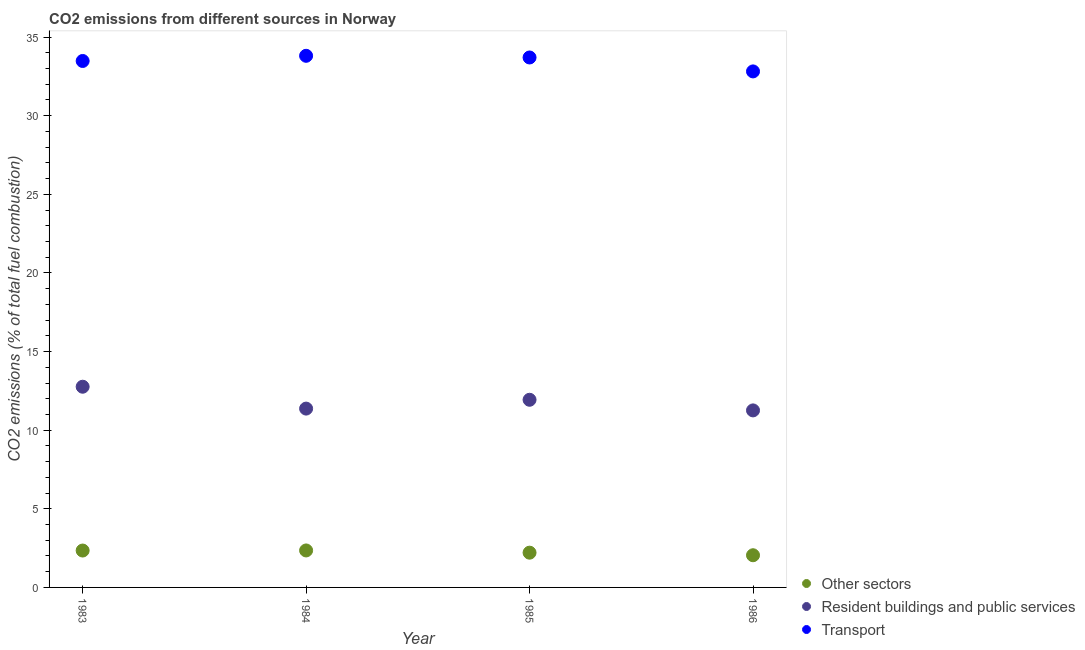What is the percentage of co2 emissions from other sectors in 1986?
Provide a succinct answer. 2.05. Across all years, what is the maximum percentage of co2 emissions from resident buildings and public services?
Your response must be concise. 12.76. Across all years, what is the minimum percentage of co2 emissions from other sectors?
Ensure brevity in your answer.  2.05. What is the total percentage of co2 emissions from transport in the graph?
Ensure brevity in your answer.  133.81. What is the difference between the percentage of co2 emissions from other sectors in 1983 and that in 1984?
Offer a very short reply. -0.01. What is the difference between the percentage of co2 emissions from other sectors in 1985 and the percentage of co2 emissions from resident buildings and public services in 1984?
Offer a terse response. -9.16. What is the average percentage of co2 emissions from resident buildings and public services per year?
Offer a very short reply. 11.83. In the year 1985, what is the difference between the percentage of co2 emissions from other sectors and percentage of co2 emissions from resident buildings and public services?
Your response must be concise. -9.72. What is the ratio of the percentage of co2 emissions from other sectors in 1984 to that in 1985?
Provide a short and direct response. 1.06. Is the difference between the percentage of co2 emissions from resident buildings and public services in 1984 and 1985 greater than the difference between the percentage of co2 emissions from other sectors in 1984 and 1985?
Provide a short and direct response. No. What is the difference between the highest and the second highest percentage of co2 emissions from other sectors?
Make the answer very short. 0.01. What is the difference between the highest and the lowest percentage of co2 emissions from transport?
Provide a succinct answer. 0.99. In how many years, is the percentage of co2 emissions from other sectors greater than the average percentage of co2 emissions from other sectors taken over all years?
Provide a succinct answer. 2. Is the sum of the percentage of co2 emissions from other sectors in 1984 and 1986 greater than the maximum percentage of co2 emissions from transport across all years?
Provide a short and direct response. No. Does the percentage of co2 emissions from other sectors monotonically increase over the years?
Give a very brief answer. No. Is the percentage of co2 emissions from transport strictly less than the percentage of co2 emissions from other sectors over the years?
Give a very brief answer. No. Are the values on the major ticks of Y-axis written in scientific E-notation?
Provide a succinct answer. No. Does the graph contain grids?
Offer a terse response. No. Where does the legend appear in the graph?
Your answer should be compact. Bottom right. How many legend labels are there?
Your answer should be compact. 3. What is the title of the graph?
Provide a succinct answer. CO2 emissions from different sources in Norway. What is the label or title of the Y-axis?
Ensure brevity in your answer.  CO2 emissions (% of total fuel combustion). What is the CO2 emissions (% of total fuel combustion) of Other sectors in 1983?
Give a very brief answer. 2.35. What is the CO2 emissions (% of total fuel combustion) in Resident buildings and public services in 1983?
Provide a succinct answer. 12.76. What is the CO2 emissions (% of total fuel combustion) of Transport in 1983?
Your answer should be compact. 33.48. What is the CO2 emissions (% of total fuel combustion) of Other sectors in 1984?
Your answer should be compact. 2.35. What is the CO2 emissions (% of total fuel combustion) in Resident buildings and public services in 1984?
Ensure brevity in your answer.  11.37. What is the CO2 emissions (% of total fuel combustion) of Transport in 1984?
Make the answer very short. 33.81. What is the CO2 emissions (% of total fuel combustion) of Other sectors in 1985?
Your answer should be very brief. 2.21. What is the CO2 emissions (% of total fuel combustion) of Resident buildings and public services in 1985?
Offer a very short reply. 11.93. What is the CO2 emissions (% of total fuel combustion) in Transport in 1985?
Offer a very short reply. 33.7. What is the CO2 emissions (% of total fuel combustion) of Other sectors in 1986?
Ensure brevity in your answer.  2.05. What is the CO2 emissions (% of total fuel combustion) of Resident buildings and public services in 1986?
Make the answer very short. 11.26. What is the CO2 emissions (% of total fuel combustion) in Transport in 1986?
Keep it short and to the point. 32.82. Across all years, what is the maximum CO2 emissions (% of total fuel combustion) of Other sectors?
Make the answer very short. 2.35. Across all years, what is the maximum CO2 emissions (% of total fuel combustion) of Resident buildings and public services?
Keep it short and to the point. 12.76. Across all years, what is the maximum CO2 emissions (% of total fuel combustion) in Transport?
Offer a very short reply. 33.81. Across all years, what is the minimum CO2 emissions (% of total fuel combustion) in Other sectors?
Offer a terse response. 2.05. Across all years, what is the minimum CO2 emissions (% of total fuel combustion) of Resident buildings and public services?
Offer a terse response. 11.26. Across all years, what is the minimum CO2 emissions (% of total fuel combustion) of Transport?
Offer a terse response. 32.82. What is the total CO2 emissions (% of total fuel combustion) in Other sectors in the graph?
Provide a short and direct response. 8.95. What is the total CO2 emissions (% of total fuel combustion) of Resident buildings and public services in the graph?
Make the answer very short. 47.33. What is the total CO2 emissions (% of total fuel combustion) of Transport in the graph?
Offer a terse response. 133.81. What is the difference between the CO2 emissions (% of total fuel combustion) of Other sectors in 1983 and that in 1984?
Provide a succinct answer. -0.01. What is the difference between the CO2 emissions (% of total fuel combustion) of Resident buildings and public services in 1983 and that in 1984?
Your answer should be very brief. 1.39. What is the difference between the CO2 emissions (% of total fuel combustion) of Transport in 1983 and that in 1984?
Your answer should be compact. -0.33. What is the difference between the CO2 emissions (% of total fuel combustion) in Other sectors in 1983 and that in 1985?
Give a very brief answer. 0.14. What is the difference between the CO2 emissions (% of total fuel combustion) of Resident buildings and public services in 1983 and that in 1985?
Provide a short and direct response. 0.83. What is the difference between the CO2 emissions (% of total fuel combustion) in Transport in 1983 and that in 1985?
Keep it short and to the point. -0.22. What is the difference between the CO2 emissions (% of total fuel combustion) of Other sectors in 1983 and that in 1986?
Your answer should be compact. 0.3. What is the difference between the CO2 emissions (% of total fuel combustion) of Resident buildings and public services in 1983 and that in 1986?
Give a very brief answer. 1.51. What is the difference between the CO2 emissions (% of total fuel combustion) in Transport in 1983 and that in 1986?
Your answer should be compact. 0.66. What is the difference between the CO2 emissions (% of total fuel combustion) in Other sectors in 1984 and that in 1985?
Your answer should be compact. 0.14. What is the difference between the CO2 emissions (% of total fuel combustion) of Resident buildings and public services in 1984 and that in 1985?
Provide a succinct answer. -0.56. What is the difference between the CO2 emissions (% of total fuel combustion) of Transport in 1984 and that in 1985?
Your answer should be very brief. 0.11. What is the difference between the CO2 emissions (% of total fuel combustion) of Other sectors in 1984 and that in 1986?
Provide a succinct answer. 0.3. What is the difference between the CO2 emissions (% of total fuel combustion) of Resident buildings and public services in 1984 and that in 1986?
Ensure brevity in your answer.  0.11. What is the difference between the CO2 emissions (% of total fuel combustion) of Other sectors in 1985 and that in 1986?
Give a very brief answer. 0.16. What is the difference between the CO2 emissions (% of total fuel combustion) of Resident buildings and public services in 1985 and that in 1986?
Offer a terse response. 0.68. What is the difference between the CO2 emissions (% of total fuel combustion) in Transport in 1985 and that in 1986?
Your answer should be very brief. 0.89. What is the difference between the CO2 emissions (% of total fuel combustion) of Other sectors in 1983 and the CO2 emissions (% of total fuel combustion) of Resident buildings and public services in 1984?
Your answer should be compact. -9.03. What is the difference between the CO2 emissions (% of total fuel combustion) in Other sectors in 1983 and the CO2 emissions (% of total fuel combustion) in Transport in 1984?
Provide a short and direct response. -31.46. What is the difference between the CO2 emissions (% of total fuel combustion) in Resident buildings and public services in 1983 and the CO2 emissions (% of total fuel combustion) in Transport in 1984?
Offer a terse response. -21.05. What is the difference between the CO2 emissions (% of total fuel combustion) in Other sectors in 1983 and the CO2 emissions (% of total fuel combustion) in Resident buildings and public services in 1985?
Give a very brief answer. -9.59. What is the difference between the CO2 emissions (% of total fuel combustion) of Other sectors in 1983 and the CO2 emissions (% of total fuel combustion) of Transport in 1985?
Your answer should be very brief. -31.36. What is the difference between the CO2 emissions (% of total fuel combustion) in Resident buildings and public services in 1983 and the CO2 emissions (% of total fuel combustion) in Transport in 1985?
Give a very brief answer. -20.94. What is the difference between the CO2 emissions (% of total fuel combustion) of Other sectors in 1983 and the CO2 emissions (% of total fuel combustion) of Resident buildings and public services in 1986?
Keep it short and to the point. -8.91. What is the difference between the CO2 emissions (% of total fuel combustion) in Other sectors in 1983 and the CO2 emissions (% of total fuel combustion) in Transport in 1986?
Your response must be concise. -30.47. What is the difference between the CO2 emissions (% of total fuel combustion) in Resident buildings and public services in 1983 and the CO2 emissions (% of total fuel combustion) in Transport in 1986?
Provide a short and direct response. -20.05. What is the difference between the CO2 emissions (% of total fuel combustion) of Other sectors in 1984 and the CO2 emissions (% of total fuel combustion) of Resident buildings and public services in 1985?
Your answer should be compact. -9.58. What is the difference between the CO2 emissions (% of total fuel combustion) in Other sectors in 1984 and the CO2 emissions (% of total fuel combustion) in Transport in 1985?
Offer a very short reply. -31.35. What is the difference between the CO2 emissions (% of total fuel combustion) in Resident buildings and public services in 1984 and the CO2 emissions (% of total fuel combustion) in Transport in 1985?
Provide a succinct answer. -22.33. What is the difference between the CO2 emissions (% of total fuel combustion) in Other sectors in 1984 and the CO2 emissions (% of total fuel combustion) in Resident buildings and public services in 1986?
Ensure brevity in your answer.  -8.91. What is the difference between the CO2 emissions (% of total fuel combustion) in Other sectors in 1984 and the CO2 emissions (% of total fuel combustion) in Transport in 1986?
Your response must be concise. -30.46. What is the difference between the CO2 emissions (% of total fuel combustion) in Resident buildings and public services in 1984 and the CO2 emissions (% of total fuel combustion) in Transport in 1986?
Provide a short and direct response. -21.44. What is the difference between the CO2 emissions (% of total fuel combustion) of Other sectors in 1985 and the CO2 emissions (% of total fuel combustion) of Resident buildings and public services in 1986?
Your answer should be very brief. -9.05. What is the difference between the CO2 emissions (% of total fuel combustion) of Other sectors in 1985 and the CO2 emissions (% of total fuel combustion) of Transport in 1986?
Give a very brief answer. -30.61. What is the difference between the CO2 emissions (% of total fuel combustion) in Resident buildings and public services in 1985 and the CO2 emissions (% of total fuel combustion) in Transport in 1986?
Your response must be concise. -20.88. What is the average CO2 emissions (% of total fuel combustion) in Other sectors per year?
Provide a short and direct response. 2.24. What is the average CO2 emissions (% of total fuel combustion) of Resident buildings and public services per year?
Provide a succinct answer. 11.83. What is the average CO2 emissions (% of total fuel combustion) of Transport per year?
Provide a short and direct response. 33.45. In the year 1983, what is the difference between the CO2 emissions (% of total fuel combustion) in Other sectors and CO2 emissions (% of total fuel combustion) in Resident buildings and public services?
Make the answer very short. -10.42. In the year 1983, what is the difference between the CO2 emissions (% of total fuel combustion) in Other sectors and CO2 emissions (% of total fuel combustion) in Transport?
Keep it short and to the point. -31.13. In the year 1983, what is the difference between the CO2 emissions (% of total fuel combustion) of Resident buildings and public services and CO2 emissions (% of total fuel combustion) of Transport?
Provide a short and direct response. -20.72. In the year 1984, what is the difference between the CO2 emissions (% of total fuel combustion) of Other sectors and CO2 emissions (% of total fuel combustion) of Resident buildings and public services?
Make the answer very short. -9.02. In the year 1984, what is the difference between the CO2 emissions (% of total fuel combustion) in Other sectors and CO2 emissions (% of total fuel combustion) in Transport?
Ensure brevity in your answer.  -31.46. In the year 1984, what is the difference between the CO2 emissions (% of total fuel combustion) in Resident buildings and public services and CO2 emissions (% of total fuel combustion) in Transport?
Make the answer very short. -22.44. In the year 1985, what is the difference between the CO2 emissions (% of total fuel combustion) of Other sectors and CO2 emissions (% of total fuel combustion) of Resident buildings and public services?
Offer a very short reply. -9.72. In the year 1985, what is the difference between the CO2 emissions (% of total fuel combustion) in Other sectors and CO2 emissions (% of total fuel combustion) in Transport?
Ensure brevity in your answer.  -31.49. In the year 1985, what is the difference between the CO2 emissions (% of total fuel combustion) in Resident buildings and public services and CO2 emissions (% of total fuel combustion) in Transport?
Offer a very short reply. -21.77. In the year 1986, what is the difference between the CO2 emissions (% of total fuel combustion) of Other sectors and CO2 emissions (% of total fuel combustion) of Resident buildings and public services?
Your answer should be compact. -9.21. In the year 1986, what is the difference between the CO2 emissions (% of total fuel combustion) of Other sectors and CO2 emissions (% of total fuel combustion) of Transport?
Ensure brevity in your answer.  -30.77. In the year 1986, what is the difference between the CO2 emissions (% of total fuel combustion) in Resident buildings and public services and CO2 emissions (% of total fuel combustion) in Transport?
Offer a terse response. -21.56. What is the ratio of the CO2 emissions (% of total fuel combustion) in Resident buildings and public services in 1983 to that in 1984?
Your answer should be compact. 1.12. What is the ratio of the CO2 emissions (% of total fuel combustion) in Transport in 1983 to that in 1984?
Provide a short and direct response. 0.99. What is the ratio of the CO2 emissions (% of total fuel combustion) of Other sectors in 1983 to that in 1985?
Keep it short and to the point. 1.06. What is the ratio of the CO2 emissions (% of total fuel combustion) in Resident buildings and public services in 1983 to that in 1985?
Your answer should be compact. 1.07. What is the ratio of the CO2 emissions (% of total fuel combustion) in Other sectors in 1983 to that in 1986?
Offer a terse response. 1.15. What is the ratio of the CO2 emissions (% of total fuel combustion) in Resident buildings and public services in 1983 to that in 1986?
Make the answer very short. 1.13. What is the ratio of the CO2 emissions (% of total fuel combustion) of Transport in 1983 to that in 1986?
Make the answer very short. 1.02. What is the ratio of the CO2 emissions (% of total fuel combustion) in Other sectors in 1984 to that in 1985?
Offer a very short reply. 1.06. What is the ratio of the CO2 emissions (% of total fuel combustion) in Resident buildings and public services in 1984 to that in 1985?
Provide a short and direct response. 0.95. What is the ratio of the CO2 emissions (% of total fuel combustion) in Transport in 1984 to that in 1985?
Ensure brevity in your answer.  1. What is the ratio of the CO2 emissions (% of total fuel combustion) of Other sectors in 1984 to that in 1986?
Offer a terse response. 1.15. What is the ratio of the CO2 emissions (% of total fuel combustion) in Resident buildings and public services in 1984 to that in 1986?
Ensure brevity in your answer.  1.01. What is the ratio of the CO2 emissions (% of total fuel combustion) in Transport in 1984 to that in 1986?
Ensure brevity in your answer.  1.03. What is the ratio of the CO2 emissions (% of total fuel combustion) in Other sectors in 1985 to that in 1986?
Make the answer very short. 1.08. What is the ratio of the CO2 emissions (% of total fuel combustion) in Resident buildings and public services in 1985 to that in 1986?
Give a very brief answer. 1.06. What is the ratio of the CO2 emissions (% of total fuel combustion) of Transport in 1985 to that in 1986?
Keep it short and to the point. 1.03. What is the difference between the highest and the second highest CO2 emissions (% of total fuel combustion) in Other sectors?
Your answer should be very brief. 0.01. What is the difference between the highest and the second highest CO2 emissions (% of total fuel combustion) of Resident buildings and public services?
Give a very brief answer. 0.83. What is the difference between the highest and the second highest CO2 emissions (% of total fuel combustion) of Transport?
Provide a short and direct response. 0.11. What is the difference between the highest and the lowest CO2 emissions (% of total fuel combustion) in Other sectors?
Offer a terse response. 0.3. What is the difference between the highest and the lowest CO2 emissions (% of total fuel combustion) in Resident buildings and public services?
Provide a short and direct response. 1.51. 